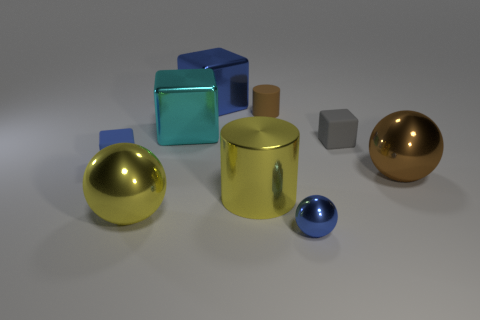Could you describe the lighting in the scene, and how it might affect the appearance of the objects? Certainly! The lighting in the image is soft and diffuse, creating gentle shadows and subtle reflections on the surfaces of the objects. Such lighting conditions can enhance the perception of depth and texture, making the metallic finishes of the objects appear more lustrous. 